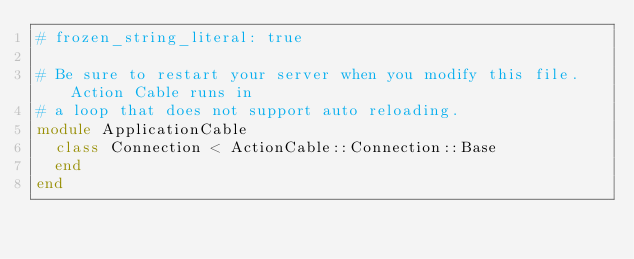Convert code to text. <code><loc_0><loc_0><loc_500><loc_500><_Ruby_># frozen_string_literal: true

# Be sure to restart your server when you modify this file. Action Cable runs in
# a loop that does not support auto reloading.
module ApplicationCable
  class Connection < ActionCable::Connection::Base
  end
end
</code> 